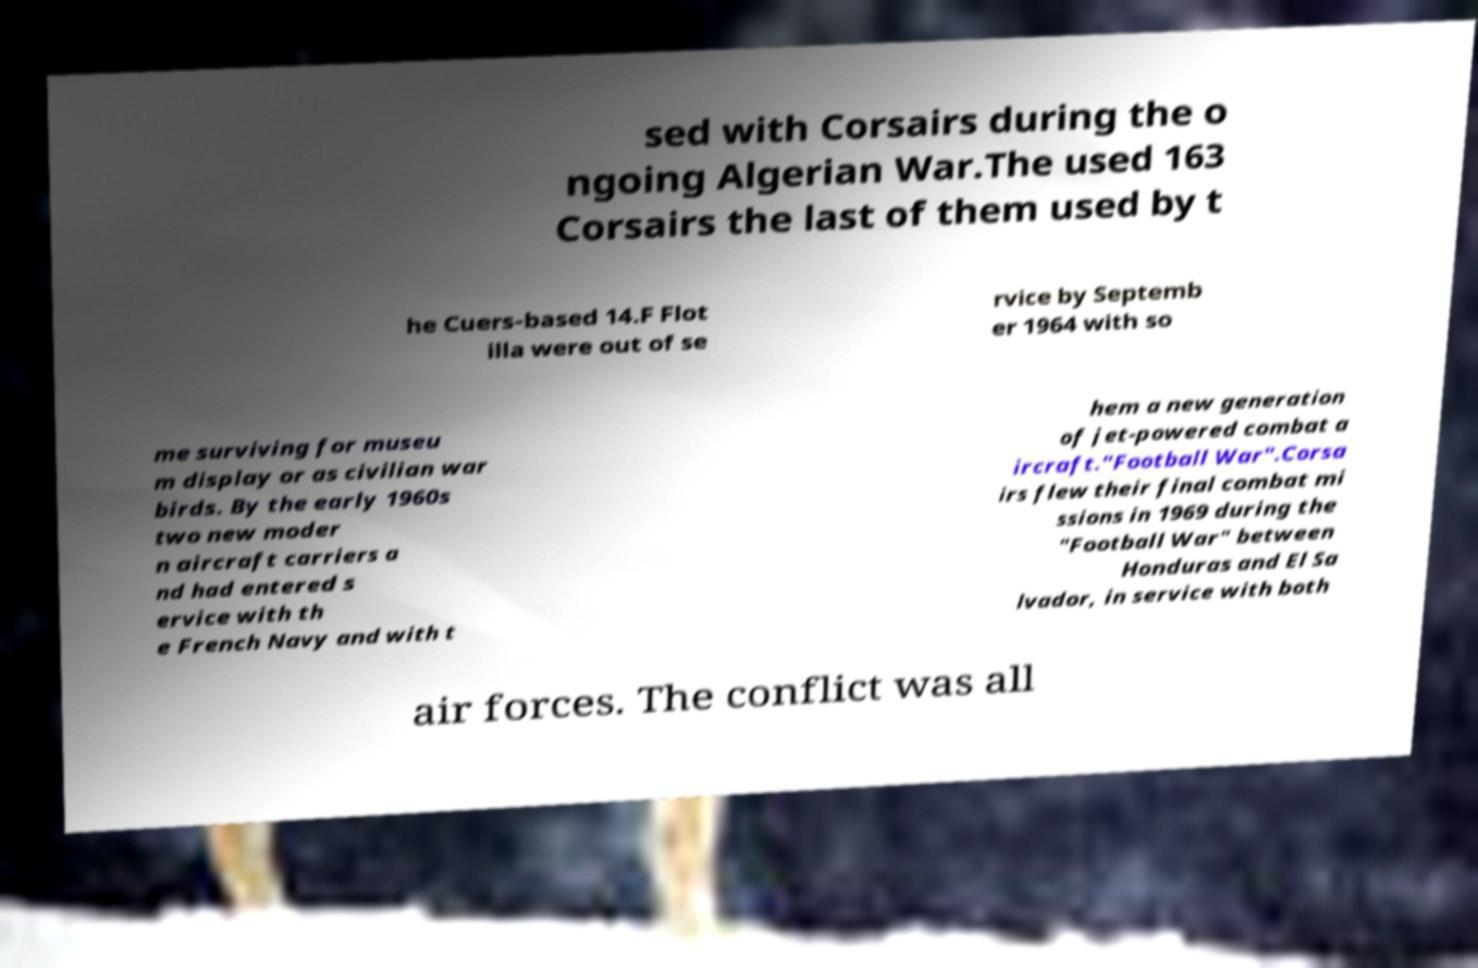What messages or text are displayed in this image? I need them in a readable, typed format. sed with Corsairs during the o ngoing Algerian War.The used 163 Corsairs the last of them used by t he Cuers-based 14.F Flot illa were out of se rvice by Septemb er 1964 with so me surviving for museu m display or as civilian war birds. By the early 1960s two new moder n aircraft carriers a nd had entered s ervice with th e French Navy and with t hem a new generation of jet-powered combat a ircraft."Football War".Corsa irs flew their final combat mi ssions in 1969 during the "Football War" between Honduras and El Sa lvador, in service with both air forces. The conflict was all 